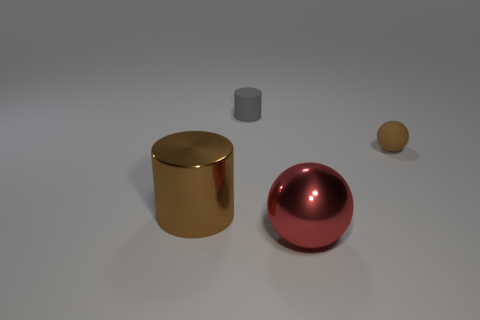Add 3 large brown cubes. How many objects exist? 7 Subtract 0 yellow cylinders. How many objects are left? 4 Subtract all big brown shiny spheres. Subtract all brown balls. How many objects are left? 3 Add 4 big brown metal cylinders. How many big brown metal cylinders are left? 5 Add 2 big yellow shiny objects. How many big yellow shiny objects exist? 2 